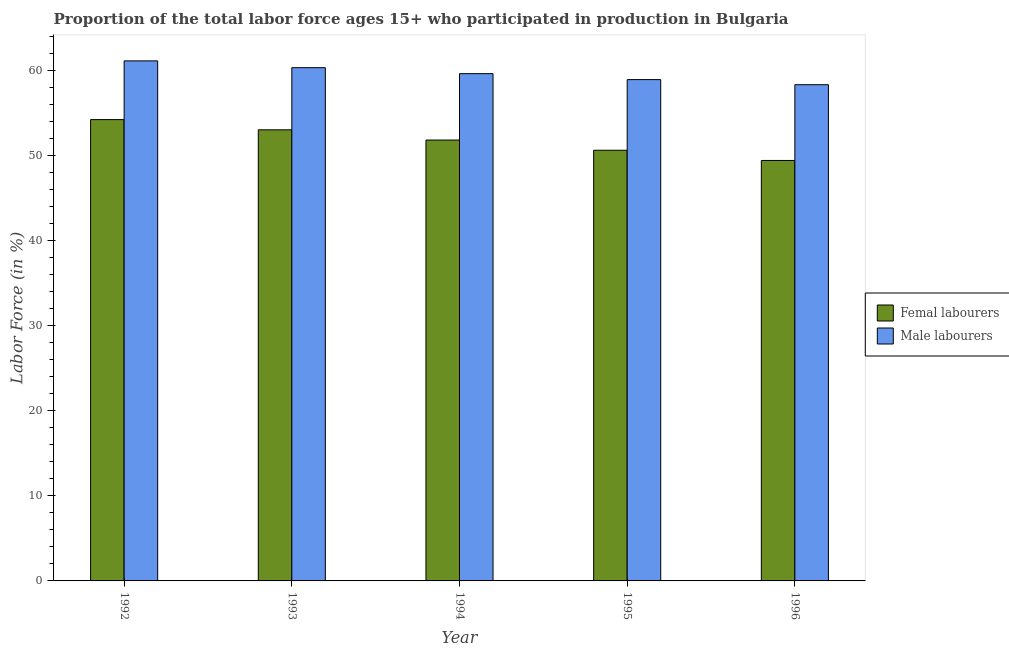How many groups of bars are there?
Ensure brevity in your answer.  5. Are the number of bars per tick equal to the number of legend labels?
Give a very brief answer. Yes. Are the number of bars on each tick of the X-axis equal?
Make the answer very short. Yes. How many bars are there on the 2nd tick from the left?
Provide a short and direct response. 2. How many bars are there on the 3rd tick from the right?
Your answer should be compact. 2. What is the label of the 4th group of bars from the left?
Keep it short and to the point. 1995. What is the percentage of male labour force in 1996?
Your answer should be compact. 58.3. Across all years, what is the maximum percentage of male labour force?
Your answer should be very brief. 61.1. Across all years, what is the minimum percentage of male labour force?
Your response must be concise. 58.3. In which year was the percentage of female labor force maximum?
Your answer should be compact. 1992. In which year was the percentage of female labor force minimum?
Provide a succinct answer. 1996. What is the total percentage of male labour force in the graph?
Offer a very short reply. 298.2. What is the difference between the percentage of female labor force in 1993 and that in 1994?
Offer a very short reply. 1.2. What is the difference between the percentage of male labour force in 1992 and the percentage of female labor force in 1995?
Offer a terse response. 2.2. What is the average percentage of female labor force per year?
Your response must be concise. 51.8. In the year 1993, what is the difference between the percentage of male labour force and percentage of female labor force?
Ensure brevity in your answer.  0. What is the ratio of the percentage of male labour force in 1994 to that in 1996?
Make the answer very short. 1.02. What is the difference between the highest and the second highest percentage of female labor force?
Provide a short and direct response. 1.2. What is the difference between the highest and the lowest percentage of female labor force?
Provide a short and direct response. 4.8. Is the sum of the percentage of female labor force in 1993 and 1994 greater than the maximum percentage of male labour force across all years?
Offer a very short reply. Yes. What does the 2nd bar from the left in 1996 represents?
Provide a short and direct response. Male labourers. What does the 1st bar from the right in 1996 represents?
Your response must be concise. Male labourers. How many bars are there?
Your answer should be compact. 10. Are all the bars in the graph horizontal?
Provide a short and direct response. No. Are the values on the major ticks of Y-axis written in scientific E-notation?
Offer a very short reply. No. Does the graph contain any zero values?
Make the answer very short. No. Does the graph contain grids?
Give a very brief answer. No. Where does the legend appear in the graph?
Ensure brevity in your answer.  Center right. What is the title of the graph?
Your answer should be very brief. Proportion of the total labor force ages 15+ who participated in production in Bulgaria. Does "Arms imports" appear as one of the legend labels in the graph?
Offer a very short reply. No. What is the Labor Force (in %) in Femal labourers in 1992?
Keep it short and to the point. 54.2. What is the Labor Force (in %) of Male labourers in 1992?
Your response must be concise. 61.1. What is the Labor Force (in %) of Male labourers in 1993?
Ensure brevity in your answer.  60.3. What is the Labor Force (in %) of Femal labourers in 1994?
Ensure brevity in your answer.  51.8. What is the Labor Force (in %) in Male labourers in 1994?
Offer a very short reply. 59.6. What is the Labor Force (in %) in Femal labourers in 1995?
Your answer should be very brief. 50.6. What is the Labor Force (in %) of Male labourers in 1995?
Your answer should be very brief. 58.9. What is the Labor Force (in %) in Femal labourers in 1996?
Give a very brief answer. 49.4. What is the Labor Force (in %) of Male labourers in 1996?
Make the answer very short. 58.3. Across all years, what is the maximum Labor Force (in %) of Femal labourers?
Provide a succinct answer. 54.2. Across all years, what is the maximum Labor Force (in %) of Male labourers?
Give a very brief answer. 61.1. Across all years, what is the minimum Labor Force (in %) in Femal labourers?
Make the answer very short. 49.4. Across all years, what is the minimum Labor Force (in %) in Male labourers?
Your answer should be very brief. 58.3. What is the total Labor Force (in %) in Femal labourers in the graph?
Your answer should be compact. 259. What is the total Labor Force (in %) in Male labourers in the graph?
Offer a very short reply. 298.2. What is the difference between the Labor Force (in %) of Femal labourers in 1992 and that in 1994?
Offer a terse response. 2.4. What is the difference between the Labor Force (in %) in Male labourers in 1992 and that in 1994?
Offer a terse response. 1.5. What is the difference between the Labor Force (in %) of Femal labourers in 1992 and that in 1995?
Your answer should be very brief. 3.6. What is the difference between the Labor Force (in %) of Femal labourers in 1992 and that in 1996?
Your answer should be very brief. 4.8. What is the difference between the Labor Force (in %) of Male labourers in 1992 and that in 1996?
Make the answer very short. 2.8. What is the difference between the Labor Force (in %) of Male labourers in 1993 and that in 1994?
Provide a short and direct response. 0.7. What is the difference between the Labor Force (in %) in Male labourers in 1993 and that in 1995?
Offer a very short reply. 1.4. What is the difference between the Labor Force (in %) of Femal labourers in 1994 and that in 1995?
Your answer should be compact. 1.2. What is the difference between the Labor Force (in %) in Femal labourers in 1994 and that in 1996?
Provide a short and direct response. 2.4. What is the difference between the Labor Force (in %) in Male labourers in 1994 and that in 1996?
Keep it short and to the point. 1.3. What is the difference between the Labor Force (in %) of Femal labourers in 1995 and that in 1996?
Provide a succinct answer. 1.2. What is the difference between the Labor Force (in %) in Male labourers in 1995 and that in 1996?
Your response must be concise. 0.6. What is the difference between the Labor Force (in %) in Femal labourers in 1992 and the Labor Force (in %) in Male labourers in 1994?
Offer a very short reply. -5.4. What is the difference between the Labor Force (in %) of Femal labourers in 1992 and the Labor Force (in %) of Male labourers in 1996?
Keep it short and to the point. -4.1. What is the difference between the Labor Force (in %) in Femal labourers in 1993 and the Labor Force (in %) in Male labourers in 1994?
Your answer should be very brief. -6.6. What is the difference between the Labor Force (in %) in Femal labourers in 1993 and the Labor Force (in %) in Male labourers in 1995?
Give a very brief answer. -5.9. What is the difference between the Labor Force (in %) of Femal labourers in 1993 and the Labor Force (in %) of Male labourers in 1996?
Your answer should be very brief. -5.3. What is the difference between the Labor Force (in %) in Femal labourers in 1994 and the Labor Force (in %) in Male labourers in 1995?
Your answer should be compact. -7.1. What is the average Labor Force (in %) in Femal labourers per year?
Make the answer very short. 51.8. What is the average Labor Force (in %) in Male labourers per year?
Keep it short and to the point. 59.64. In the year 1993, what is the difference between the Labor Force (in %) of Femal labourers and Labor Force (in %) of Male labourers?
Offer a very short reply. -7.3. In the year 1995, what is the difference between the Labor Force (in %) of Femal labourers and Labor Force (in %) of Male labourers?
Your answer should be compact. -8.3. In the year 1996, what is the difference between the Labor Force (in %) in Femal labourers and Labor Force (in %) in Male labourers?
Provide a succinct answer. -8.9. What is the ratio of the Labor Force (in %) in Femal labourers in 1992 to that in 1993?
Ensure brevity in your answer.  1.02. What is the ratio of the Labor Force (in %) in Male labourers in 1992 to that in 1993?
Offer a very short reply. 1.01. What is the ratio of the Labor Force (in %) in Femal labourers in 1992 to that in 1994?
Give a very brief answer. 1.05. What is the ratio of the Labor Force (in %) in Male labourers in 1992 to that in 1994?
Give a very brief answer. 1.03. What is the ratio of the Labor Force (in %) in Femal labourers in 1992 to that in 1995?
Keep it short and to the point. 1.07. What is the ratio of the Labor Force (in %) in Male labourers in 1992 to that in 1995?
Your answer should be very brief. 1.04. What is the ratio of the Labor Force (in %) of Femal labourers in 1992 to that in 1996?
Make the answer very short. 1.1. What is the ratio of the Labor Force (in %) of Male labourers in 1992 to that in 1996?
Offer a very short reply. 1.05. What is the ratio of the Labor Force (in %) of Femal labourers in 1993 to that in 1994?
Your answer should be very brief. 1.02. What is the ratio of the Labor Force (in %) in Male labourers in 1993 to that in 1994?
Give a very brief answer. 1.01. What is the ratio of the Labor Force (in %) of Femal labourers in 1993 to that in 1995?
Provide a succinct answer. 1.05. What is the ratio of the Labor Force (in %) in Male labourers in 1993 to that in 1995?
Ensure brevity in your answer.  1.02. What is the ratio of the Labor Force (in %) of Femal labourers in 1993 to that in 1996?
Offer a terse response. 1.07. What is the ratio of the Labor Force (in %) of Male labourers in 1993 to that in 1996?
Your answer should be very brief. 1.03. What is the ratio of the Labor Force (in %) of Femal labourers in 1994 to that in 1995?
Your answer should be compact. 1.02. What is the ratio of the Labor Force (in %) of Male labourers in 1994 to that in 1995?
Your response must be concise. 1.01. What is the ratio of the Labor Force (in %) of Femal labourers in 1994 to that in 1996?
Ensure brevity in your answer.  1.05. What is the ratio of the Labor Force (in %) of Male labourers in 1994 to that in 1996?
Ensure brevity in your answer.  1.02. What is the ratio of the Labor Force (in %) of Femal labourers in 1995 to that in 1996?
Make the answer very short. 1.02. What is the ratio of the Labor Force (in %) in Male labourers in 1995 to that in 1996?
Give a very brief answer. 1.01. What is the difference between the highest and the second highest Labor Force (in %) in Femal labourers?
Make the answer very short. 1.2. What is the difference between the highest and the second highest Labor Force (in %) of Male labourers?
Offer a terse response. 0.8. What is the difference between the highest and the lowest Labor Force (in %) in Femal labourers?
Provide a short and direct response. 4.8. 